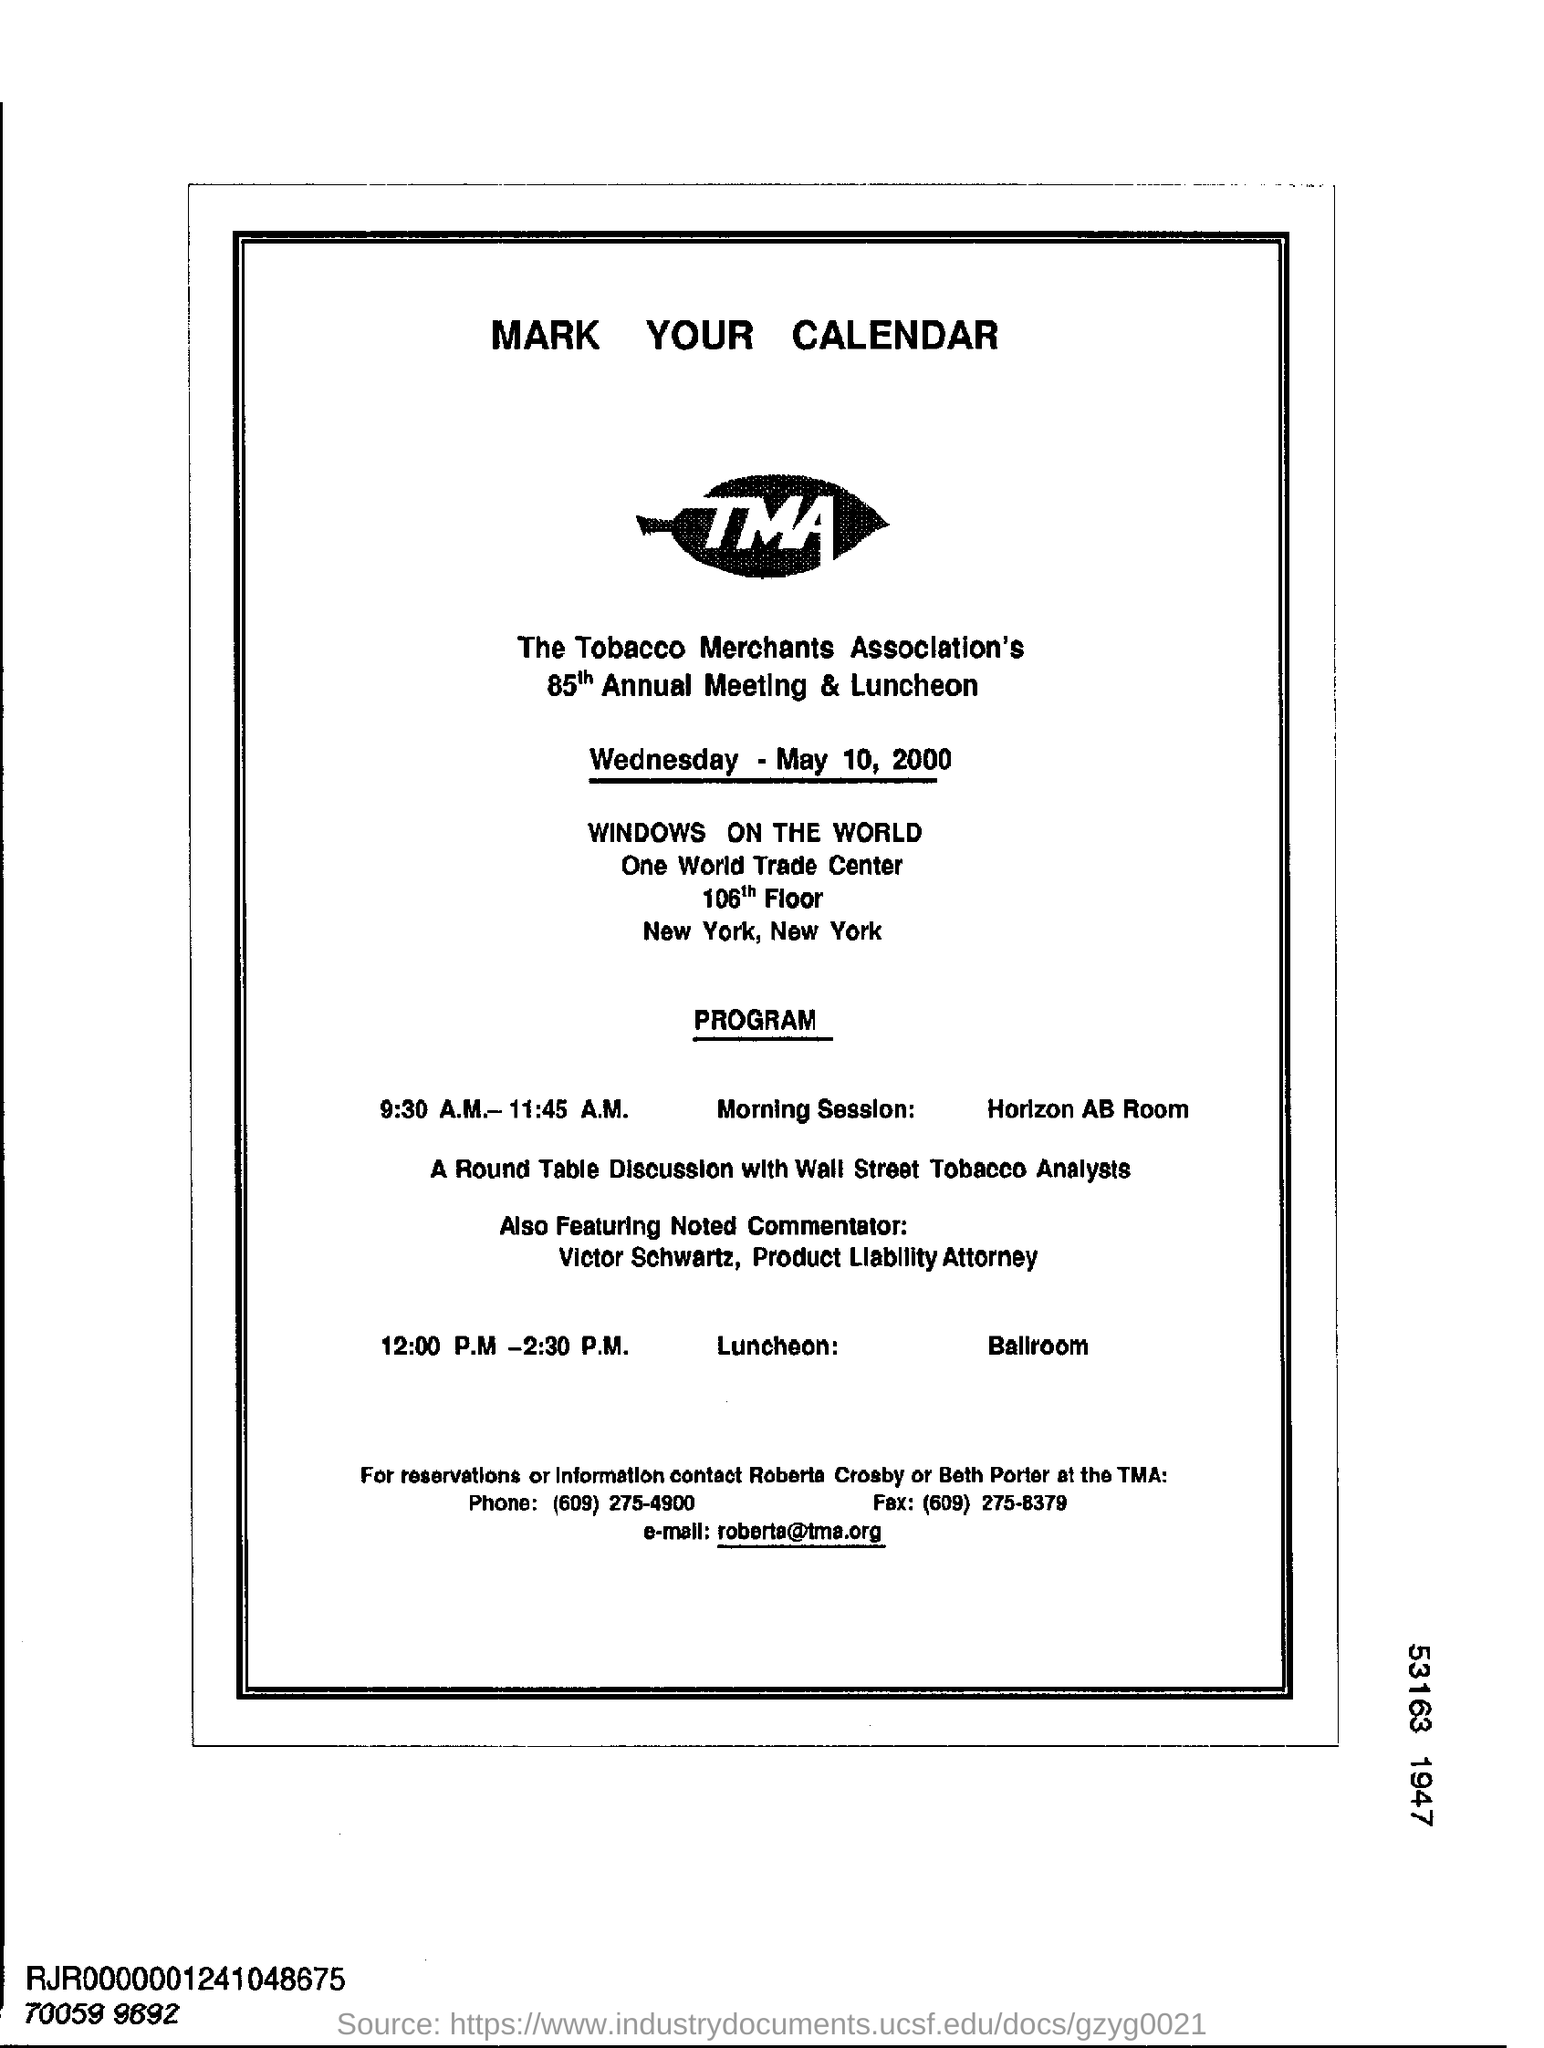Draw attention to some important aspects in this diagram. The timing for the morning session is from 9:30 A.M. to 11:45 A.M. The 85th Annual Meeting is scheduled to take place on Wednesday, May 10, 2000. The Tobacco Merchants Association's 85th Annual Meeting is mentioned in the text. To make a reservation or obtain information, please call (609) 275-4900. 